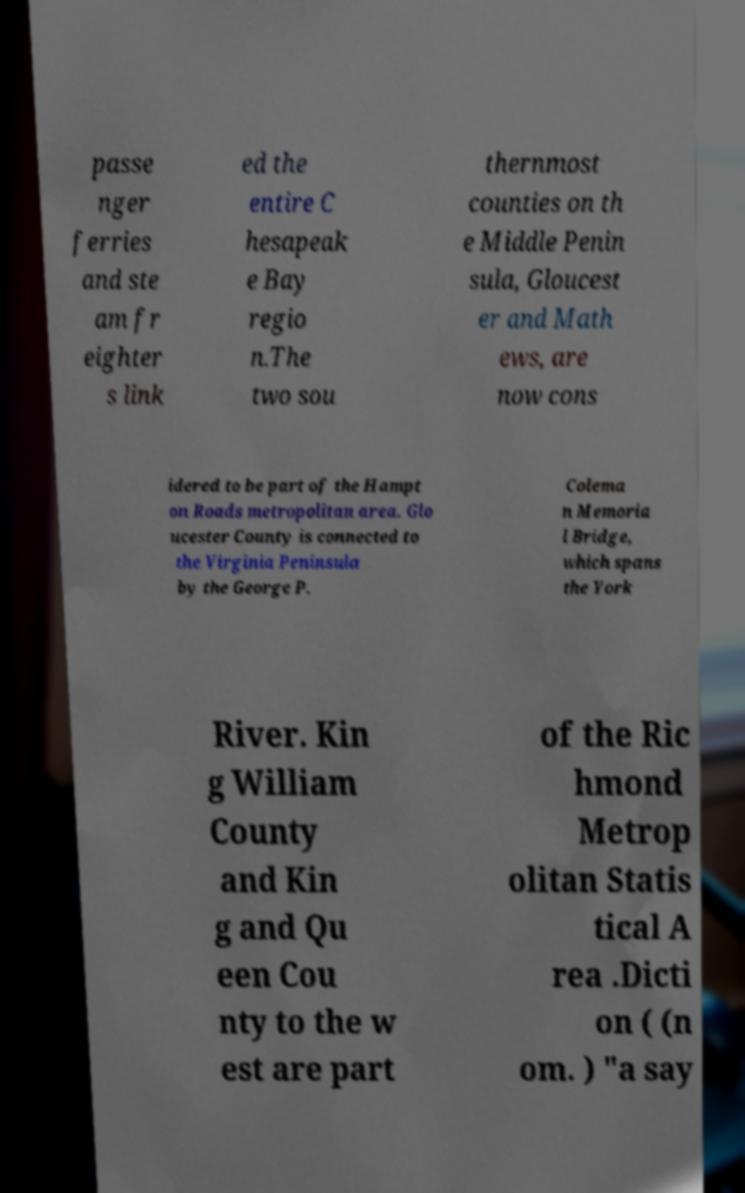Could you assist in decoding the text presented in this image and type it out clearly? passe nger ferries and ste am fr eighter s link ed the entire C hesapeak e Bay regio n.The two sou thernmost counties on th e Middle Penin sula, Gloucest er and Math ews, are now cons idered to be part of the Hampt on Roads metropolitan area. Glo ucester County is connected to the Virginia Peninsula by the George P. Colema n Memoria l Bridge, which spans the York River. Kin g William County and Kin g and Qu een Cou nty to the w est are part of the Ric hmond Metrop olitan Statis tical A rea .Dicti on ( (n om. ) "a say 